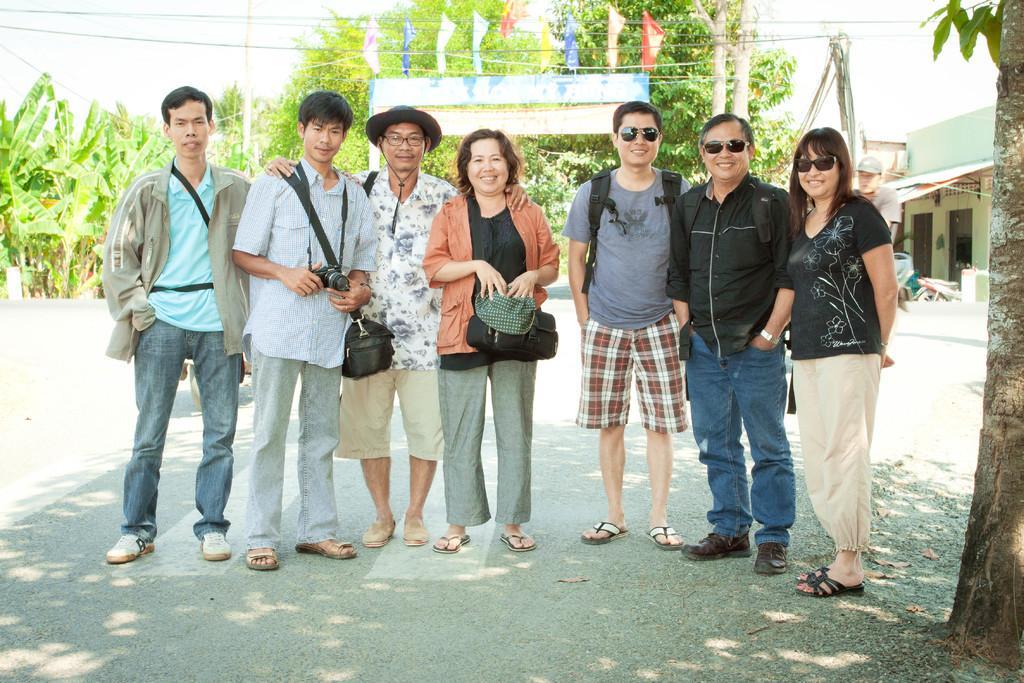Please provide a concise description of this image. This picture is clicked outside. In the center we can see the group of people wearing bags, smiling and standing on the ground. On the right there is a woman wearing t-shirt, smiling and standing on the ground. In the right corner we can see the trunk of a tree and the green leaves. In the background we can see the sky, buildings, a person seems to be walking on the ground and we can see the flags, trees and some objects lying on the ground. 